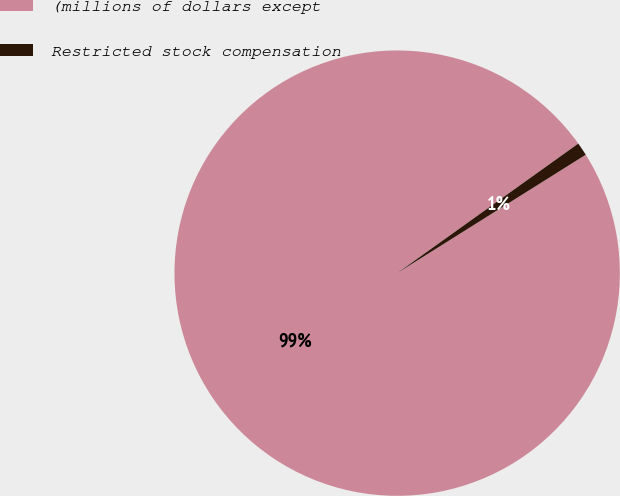Convert chart. <chart><loc_0><loc_0><loc_500><loc_500><pie_chart><fcel>(millions of dollars except<fcel>Restricted stock compensation<nl><fcel>99.04%<fcel>0.96%<nl></chart> 